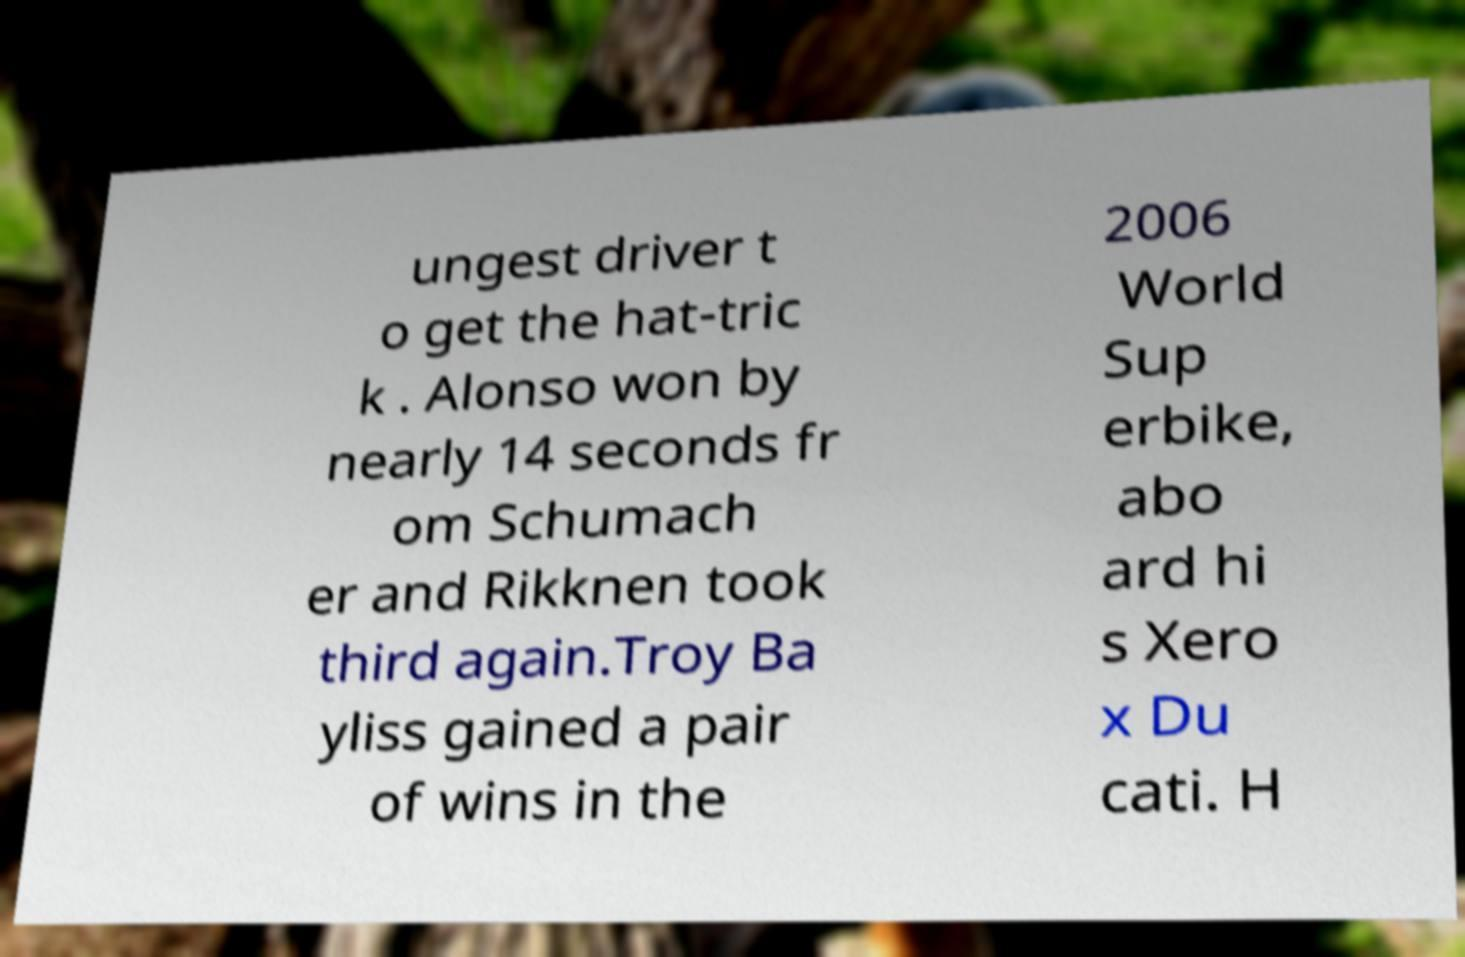For documentation purposes, I need the text within this image transcribed. Could you provide that? ungest driver t o get the hat-tric k . Alonso won by nearly 14 seconds fr om Schumach er and Rikknen took third again.Troy Ba yliss gained a pair of wins in the 2006 World Sup erbike, abo ard hi s Xero x Du cati. H 